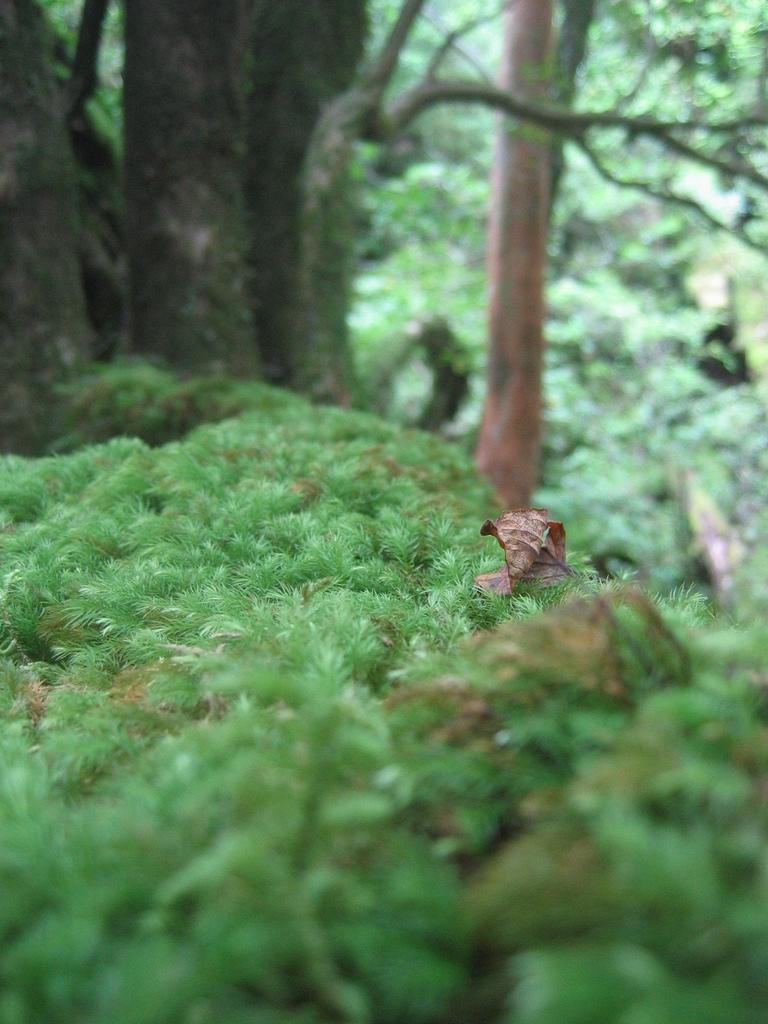What type of vegetation can be seen in the image? There is grass in the image. What can be seen in the distance in the image? There are trees in the background of the image. What type of yarn is being used to create the trees in the image? There is no yarn present in the image; the trees are depicted using a different medium, such as paint or photography. 